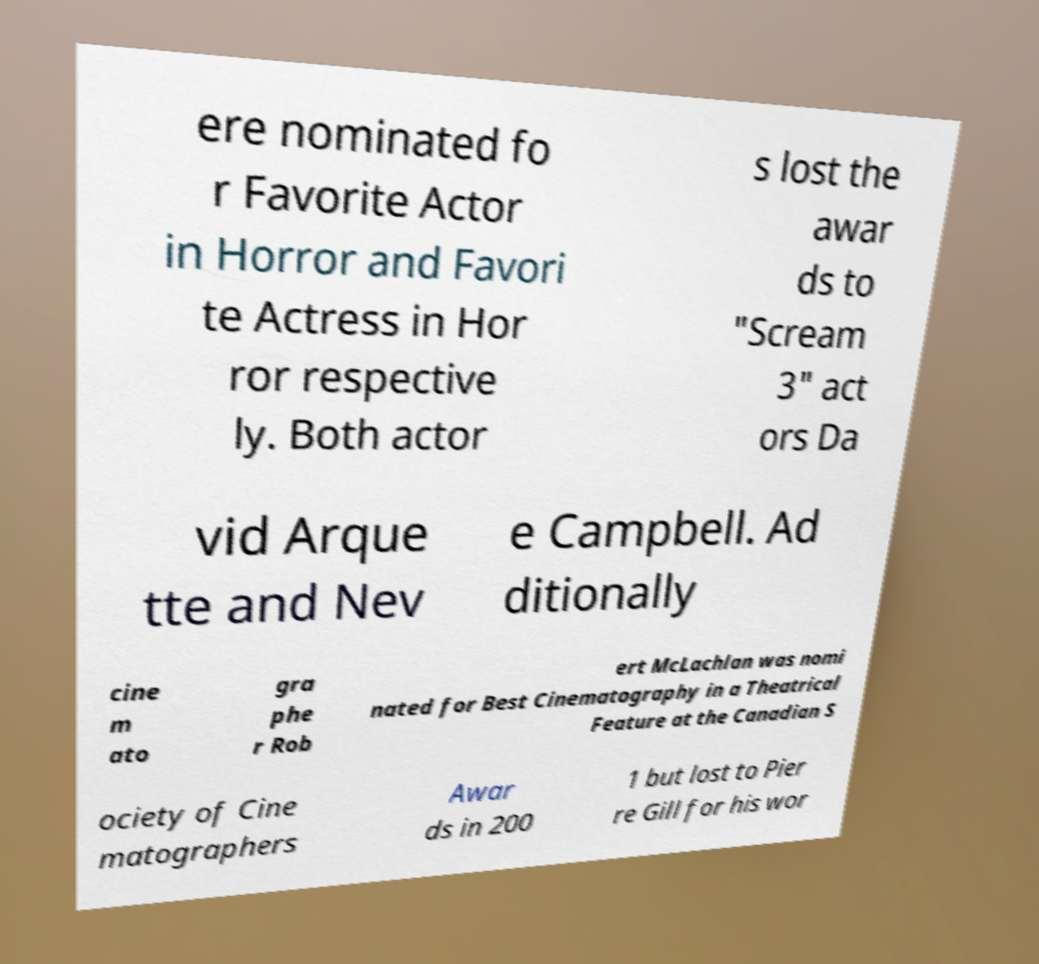For documentation purposes, I need the text within this image transcribed. Could you provide that? ere nominated fo r Favorite Actor in Horror and Favori te Actress in Hor ror respective ly. Both actor s lost the awar ds to "Scream 3" act ors Da vid Arque tte and Nev e Campbell. Ad ditionally cine m ato gra phe r Rob ert McLachlan was nomi nated for Best Cinematography in a Theatrical Feature at the Canadian S ociety of Cine matographers Awar ds in 200 1 but lost to Pier re Gill for his wor 